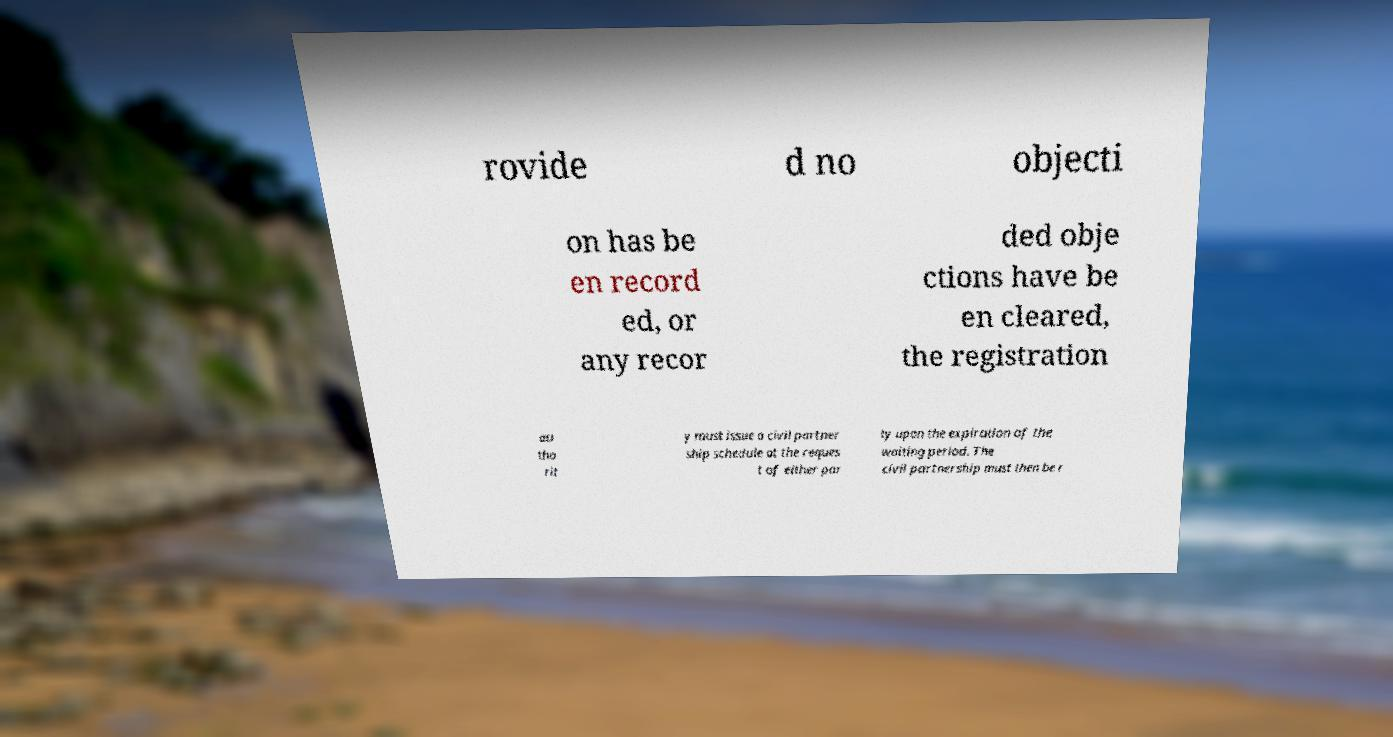There's text embedded in this image that I need extracted. Can you transcribe it verbatim? rovide d no objecti on has be en record ed, or any recor ded obje ctions have be en cleared, the registration au tho rit y must issue a civil partner ship schedule at the reques t of either par ty upon the expiration of the waiting period. The civil partnership must then be r 